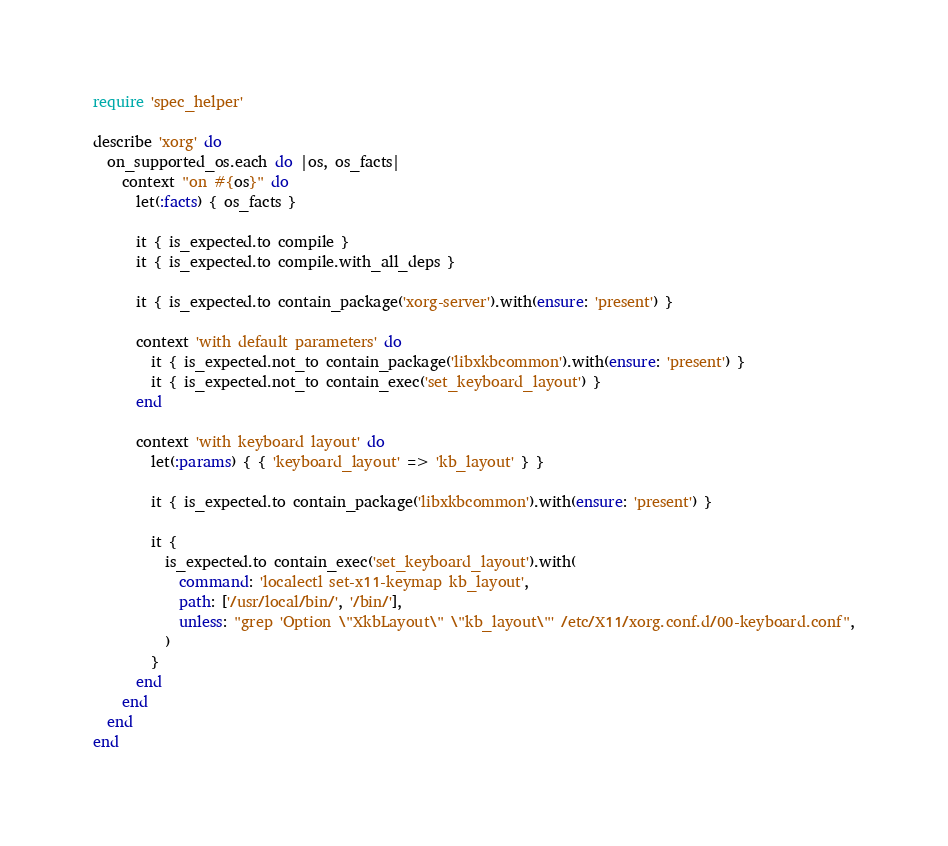Convert code to text. <code><loc_0><loc_0><loc_500><loc_500><_Ruby_>require 'spec_helper'

describe 'xorg' do
  on_supported_os.each do |os, os_facts|
    context "on #{os}" do
      let(:facts) { os_facts }

      it { is_expected.to compile }
      it { is_expected.to compile.with_all_deps }

      it { is_expected.to contain_package('xorg-server').with(ensure: 'present') }

      context 'with default parameters' do
        it { is_expected.not_to contain_package('libxkbcommon').with(ensure: 'present') }
        it { is_expected.not_to contain_exec('set_keyboard_layout') }
      end

      context 'with keyboard layout' do
        let(:params) { { 'keyboard_layout' => 'kb_layout' } }

        it { is_expected.to contain_package('libxkbcommon').with(ensure: 'present') }

        it {
          is_expected.to contain_exec('set_keyboard_layout').with(
            command: 'localectl set-x11-keymap kb_layout',
            path: ['/usr/local/bin/', '/bin/'],
            unless: "grep 'Option \"XkbLayout\" \"kb_layout\"' /etc/X11/xorg.conf.d/00-keyboard.conf",
          )
        }
      end
    end
  end
end
</code> 